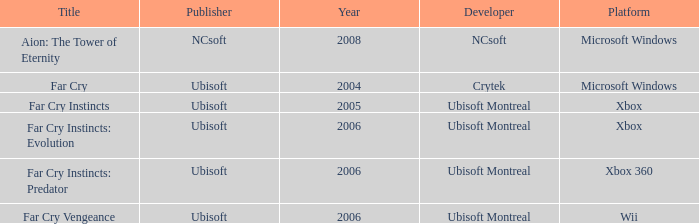Which publisher has Far Cry as the title? Ubisoft. 